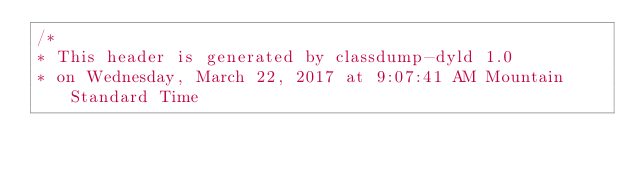<code> <loc_0><loc_0><loc_500><loc_500><_C_>/*
* This header is generated by classdump-dyld 1.0
* on Wednesday, March 22, 2017 at 9:07:41 AM Mountain Standard Time</code> 